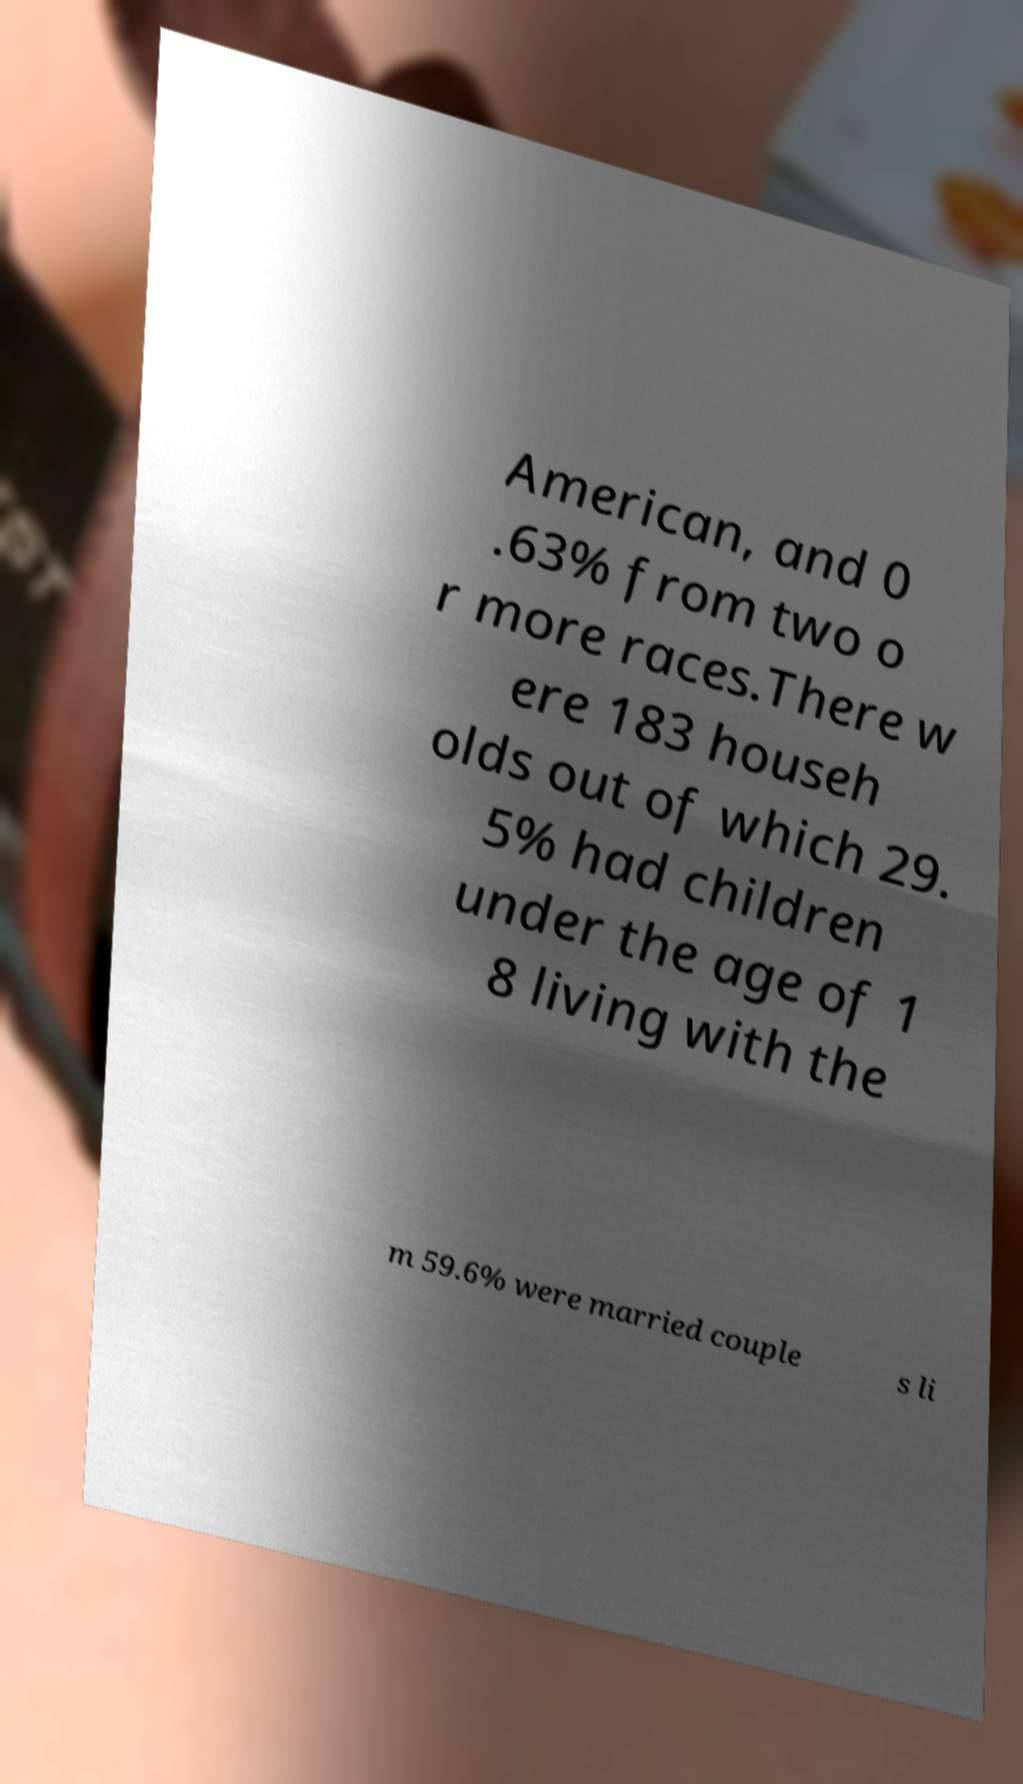Can you read and provide the text displayed in the image?This photo seems to have some interesting text. Can you extract and type it out for me? American, and 0 .63% from two o r more races.There w ere 183 househ olds out of which 29. 5% had children under the age of 1 8 living with the m 59.6% were married couple s li 